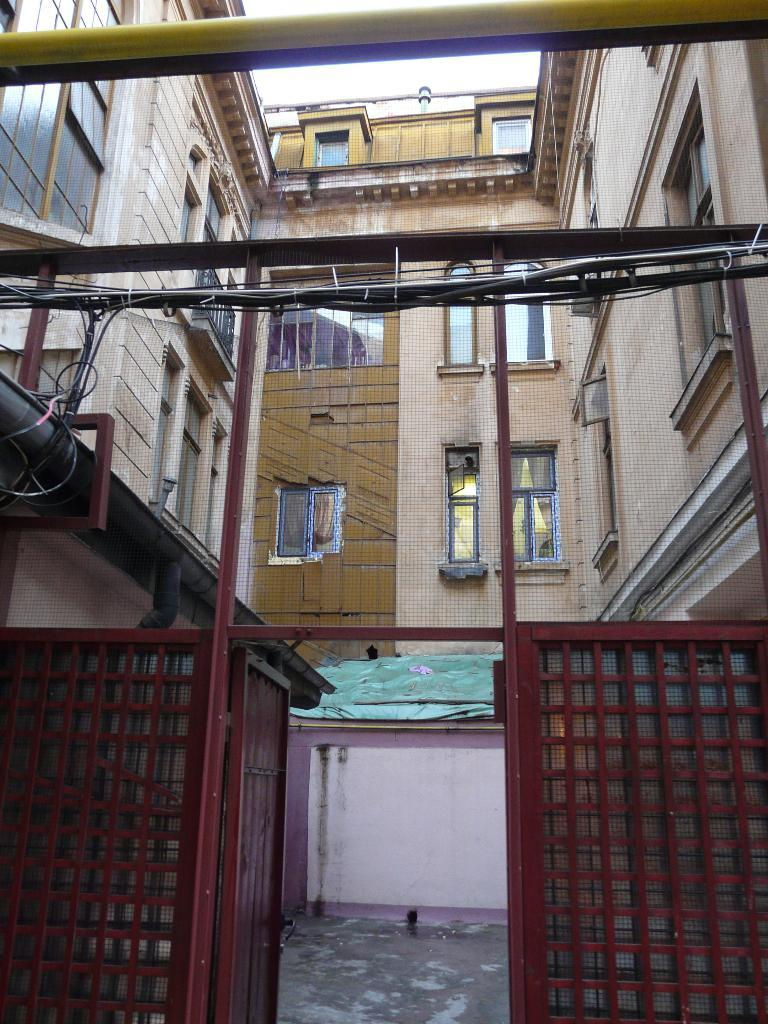What type of structures can be seen in the image? There are buildings in the image. What feature is common to many of the buildings? There are windows in the image. What type of infrastructure is visible in the image? There are pipes in the image. What is the color of the gate in the image? There is a maroon color gate in the image. What type of cover is present in the image? There is a green color cover in the image. What type of government is depicted in the image? There is no depiction of a government in the image; it features buildings, windows, pipes, a maroon gate, and a green cover. What type of quilt is shown on the windows in the image? There are no quilts present on the windows in the image; it only features windows as part of the buildings. 